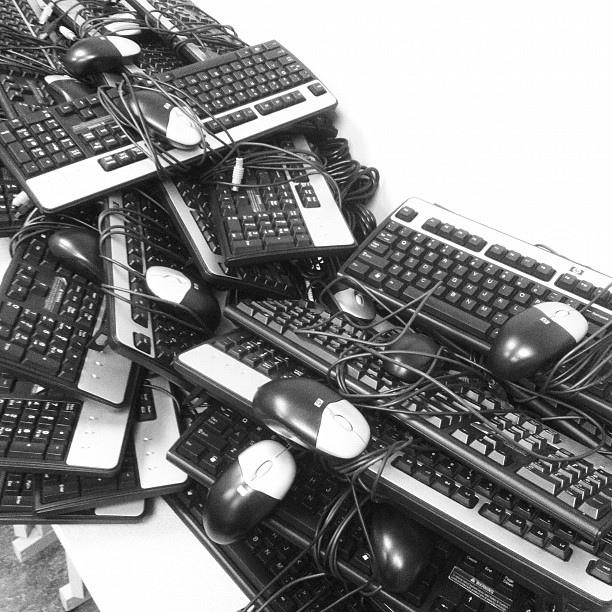Which one of these items would pair well with the items in the photo? monitor 